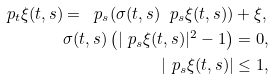<formula> <loc_0><loc_0><loc_500><loc_500>\ p _ { t } \xi ( t , s ) = \ p _ { s } ( \sigma ( t , s ) \ p _ { s } \xi ( t , s ) ) & + \xi , \\ \sigma ( t , s ) \left ( | \ p _ { s } \xi ( t , s ) | ^ { 2 } - 1 \right ) & = 0 , \\ | \ p _ { s } \xi ( t , s ) | & \leq 1 ,</formula> 